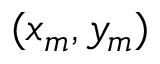<formula> <loc_0><loc_0><loc_500><loc_500>( x _ { m } , y _ { m } )</formula> 